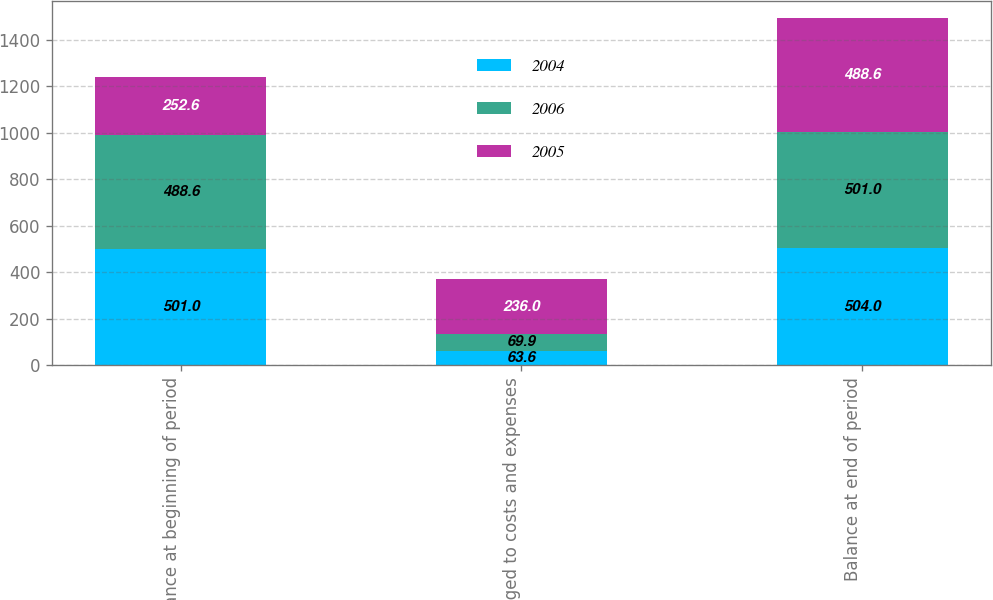Convert chart. <chart><loc_0><loc_0><loc_500><loc_500><stacked_bar_chart><ecel><fcel>Balance at beginning of period<fcel>Charged to costs and expenses<fcel>Balance at end of period<nl><fcel>2004<fcel>501<fcel>63.6<fcel>504<nl><fcel>2006<fcel>488.6<fcel>69.9<fcel>501<nl><fcel>2005<fcel>252.6<fcel>236<fcel>488.6<nl></chart> 